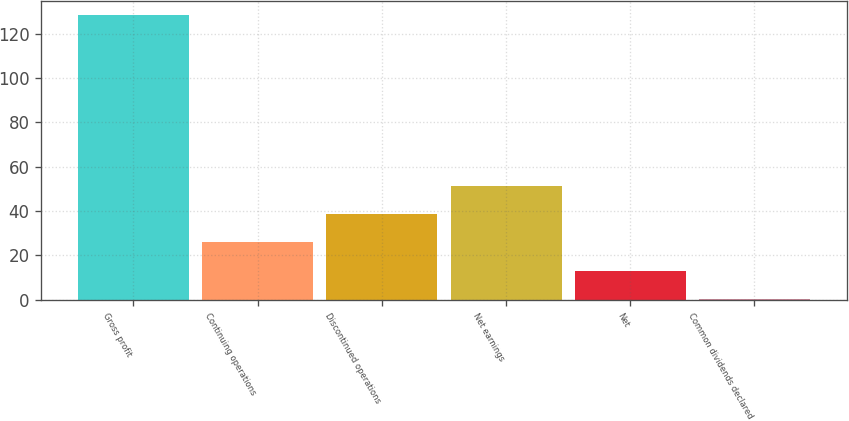<chart> <loc_0><loc_0><loc_500><loc_500><bar_chart><fcel>Gross profit<fcel>Continuing operations<fcel>Discontinued operations<fcel>Net earnings<fcel>Net<fcel>Common dividends declared<nl><fcel>128.4<fcel>25.79<fcel>38.62<fcel>51.45<fcel>12.96<fcel>0.13<nl></chart> 